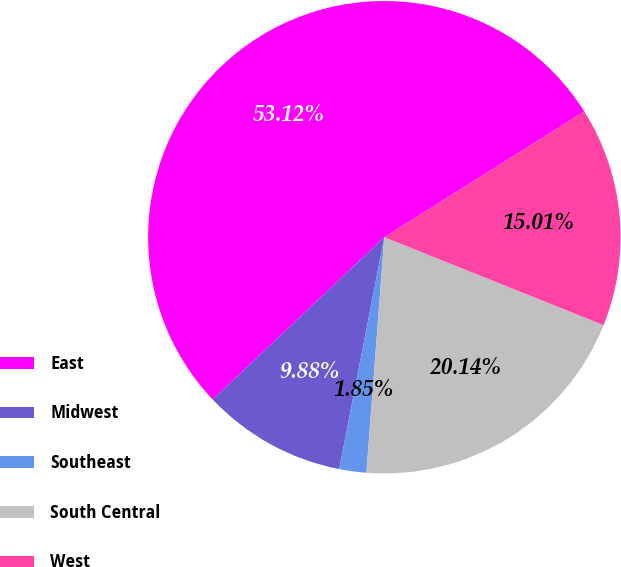Convert chart. <chart><loc_0><loc_0><loc_500><loc_500><pie_chart><fcel>East<fcel>Midwest<fcel>Southeast<fcel>South Central<fcel>West<nl><fcel>53.12%<fcel>9.88%<fcel>1.85%<fcel>20.14%<fcel>15.01%<nl></chart> 